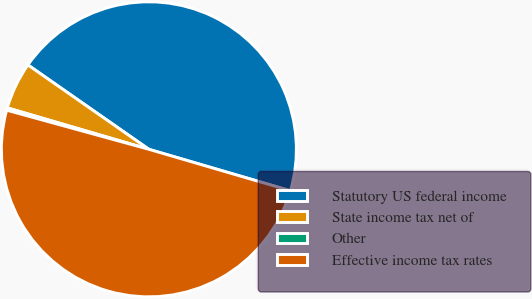<chart> <loc_0><loc_0><loc_500><loc_500><pie_chart><fcel>Statutory US federal income<fcel>State income tax net of<fcel>Other<fcel>Effective income tax rates<nl><fcel>44.84%<fcel>5.16%<fcel>0.26%<fcel>49.74%<nl></chart> 